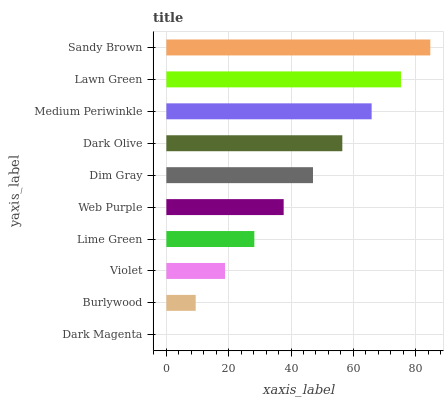Is Dark Magenta the minimum?
Answer yes or no. Yes. Is Sandy Brown the maximum?
Answer yes or no. Yes. Is Burlywood the minimum?
Answer yes or no. No. Is Burlywood the maximum?
Answer yes or no. No. Is Burlywood greater than Dark Magenta?
Answer yes or no. Yes. Is Dark Magenta less than Burlywood?
Answer yes or no. Yes. Is Dark Magenta greater than Burlywood?
Answer yes or no. No. Is Burlywood less than Dark Magenta?
Answer yes or no. No. Is Dim Gray the high median?
Answer yes or no. Yes. Is Web Purple the low median?
Answer yes or no. Yes. Is Violet the high median?
Answer yes or no. No. Is Dim Gray the low median?
Answer yes or no. No. 